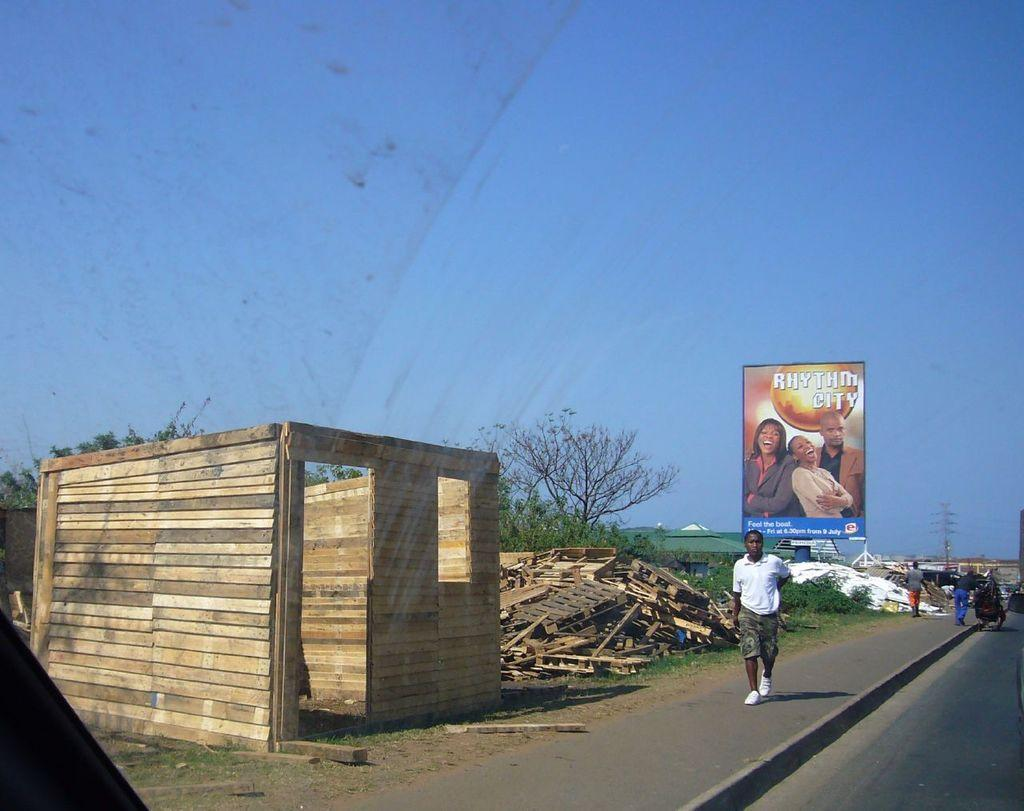<image>
Share a concise interpretation of the image provided. a sign with rhythm city written on it 